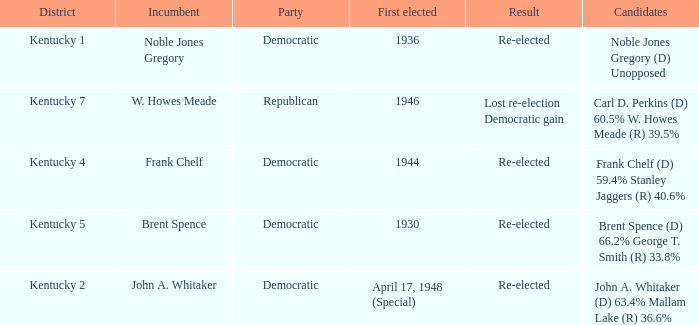Which party won in the election in voting district Kentucky 5? Democratic. 